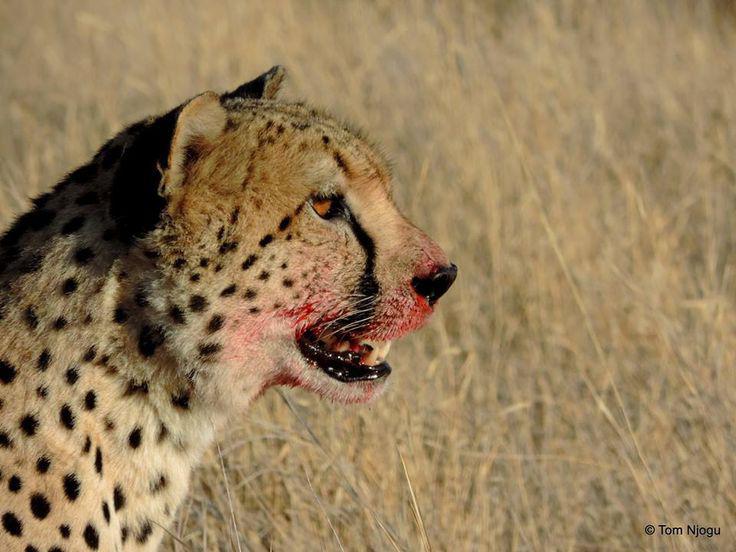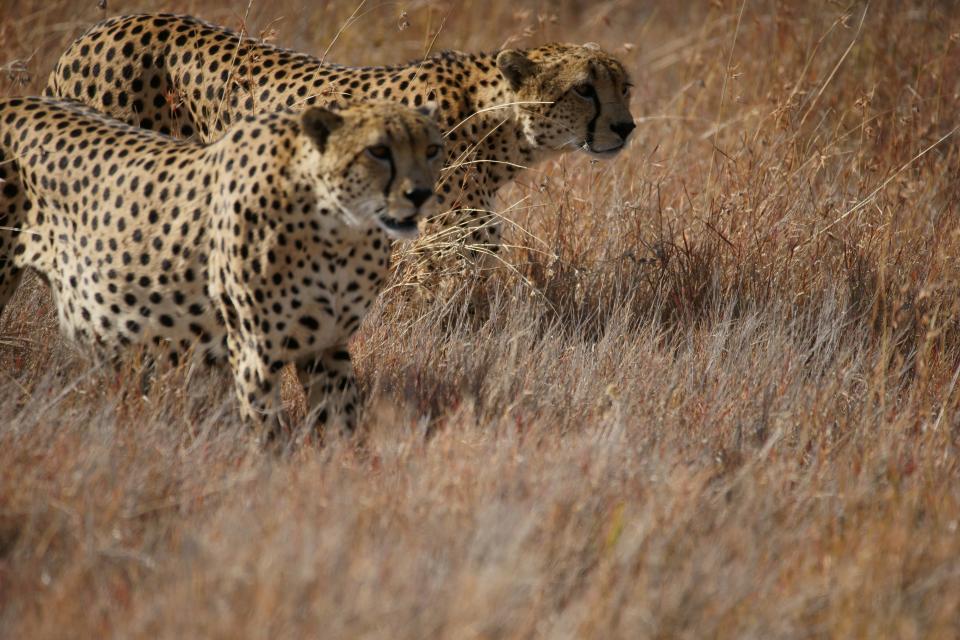The first image is the image on the left, the second image is the image on the right. Given the left and right images, does the statement "There is at least two cheetahs in the left image." hold true? Answer yes or no. No. The first image is the image on the left, the second image is the image on the right. For the images shown, is this caption "One image includes three cheetahs of the same size sitting upright in a row in lookalike poses." true? Answer yes or no. No. 